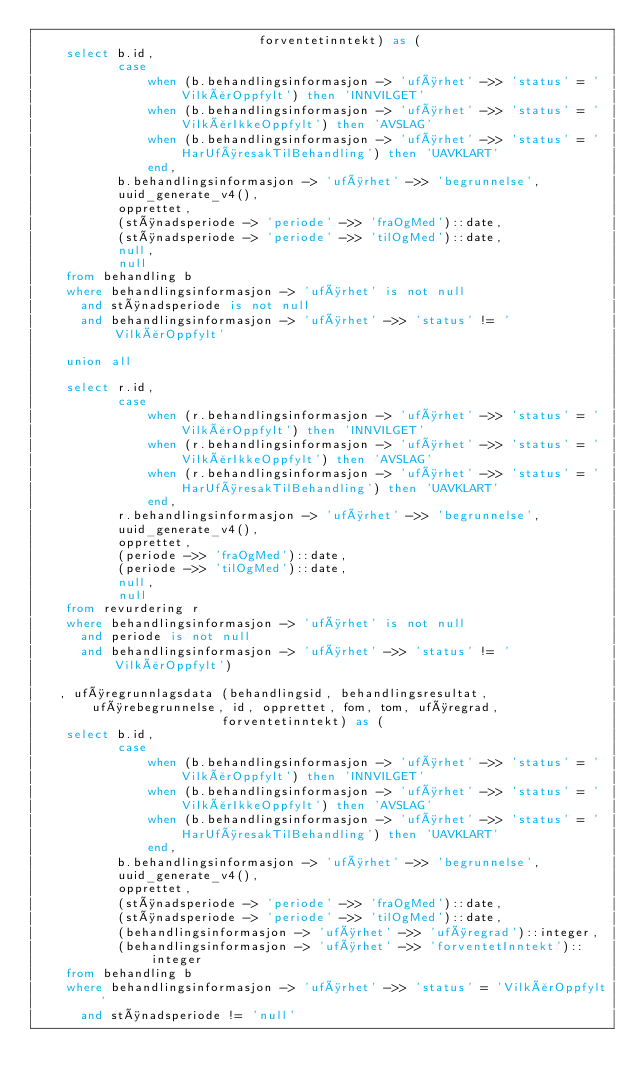<code> <loc_0><loc_0><loc_500><loc_500><_SQL_>                              forventetinntekt) as (
    select b.id,
           case
               when (b.behandlingsinformasjon -> 'uførhet' ->> 'status' = 'VilkårOppfylt') then 'INNVILGET'
               when (b.behandlingsinformasjon -> 'uførhet' ->> 'status' = 'VilkårIkkeOppfylt') then 'AVSLAG'
               when (b.behandlingsinformasjon -> 'uførhet' ->> 'status' = 'HarUføresakTilBehandling') then 'UAVKLART'
               end,
           b.behandlingsinformasjon -> 'uførhet' ->> 'begrunnelse',
           uuid_generate_v4(),
           opprettet,
           (stønadsperiode -> 'periode' ->> 'fraOgMed')::date,
           (stønadsperiode -> 'periode' ->> 'tilOgMed')::date,
           null,
           null
    from behandling b
    where behandlingsinformasjon -> 'uførhet' is not null
      and stønadsperiode is not null
      and behandlingsinformasjon -> 'uførhet' ->> 'status' != 'VilkårOppfylt'

    union all

    select r.id,
           case
               when (r.behandlingsinformasjon -> 'uførhet' ->> 'status' = 'VilkårOppfylt') then 'INNVILGET'
               when (r.behandlingsinformasjon -> 'uførhet' ->> 'status' = 'VilkårIkkeOppfylt') then 'AVSLAG'
               when (r.behandlingsinformasjon -> 'uførhet' ->> 'status' = 'HarUføresakTilBehandling') then 'UAVKLART'
               end,
           r.behandlingsinformasjon -> 'uførhet' ->> 'begrunnelse',
           uuid_generate_v4(),
           opprettet,
           (periode ->> 'fraOgMed')::date,
           (periode ->> 'tilOgMed')::date,
           null,
           null
    from revurdering r
    where behandlingsinformasjon -> 'uførhet' is not null
      and periode is not null
      and behandlingsinformasjon -> 'uførhet' ->> 'status' != 'VilkårOppfylt')

   , uføregrunnlagsdata (behandlingsid, behandlingsresultat, uførebegrunnelse, id, opprettet, fom, tom, uføregrad,
                         forventetinntekt) as (
    select b.id,
           case
               when (b.behandlingsinformasjon -> 'uførhet' ->> 'status' = 'VilkårOppfylt') then 'INNVILGET'
               when (b.behandlingsinformasjon -> 'uførhet' ->> 'status' = 'VilkårIkkeOppfylt') then 'AVSLAG'
               when (b.behandlingsinformasjon -> 'uførhet' ->> 'status' = 'HarUføresakTilBehandling') then 'UAVKLART'
               end,
           b.behandlingsinformasjon -> 'uførhet' ->> 'begrunnelse',
           uuid_generate_v4(),
           opprettet,
           (stønadsperiode -> 'periode' ->> 'fraOgMed')::date,
           (stønadsperiode -> 'periode' ->> 'tilOgMed')::date,
           (behandlingsinformasjon -> 'uførhet' ->> 'uføregrad')::integer,
           (behandlingsinformasjon -> 'uførhet' ->> 'forventetInntekt')::integer
    from behandling b
    where behandlingsinformasjon -> 'uførhet' ->> 'status' = 'VilkårOppfylt'
      and stønadsperiode != 'null'
</code> 